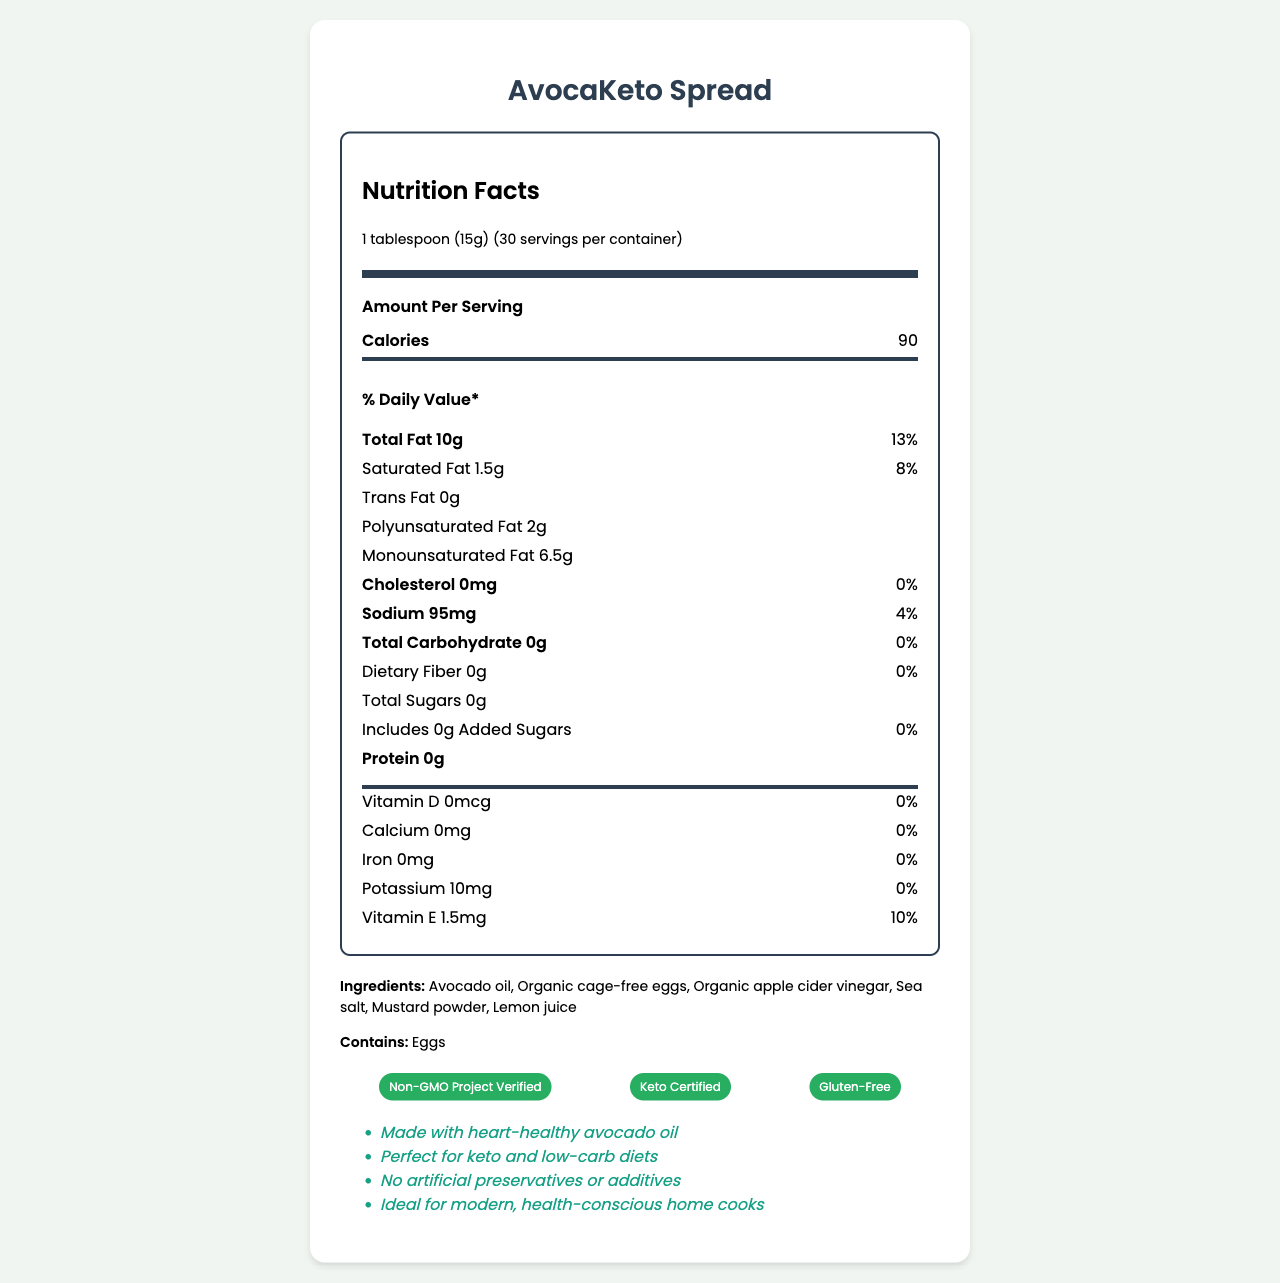what is the serving size? The serving size is explicitly stated as "1 tablespoon (15g)" in the document.
Answer: 1 tablespoon (15g) how many servings are in the container? The document states there are 30 servings per container.
Answer: 30 how many calories are in one serving? The document clearly shows that each serving contains 90 calories.
Answer: 90 calories what is the total fat content per serving? The document lists "Total Fat: 10g" under the nutrient section.
Answer: 10g what allergens are listed? The allergens section states "Contains: Eggs".
Answer: Eggs how much sodium does a serving contain? The document mentions that each serving contains "Sodium: 95mg".
Answer: 95mg how much protein is in a serving of AvocaKeto Spread? The protein content per serving is listed as 0g in the document.
Answer: 0g which certification(s) does AvocaKeto Spread have? A. Organic Certified B. Non-GMO Project Verified C. Vegan Certified The certifications section lists "Non-GMO Project Verified" among others.
Answer: B. Non-GMO Project Verified which ingredient is not present in AvocaKeto Spread? A. Lemon Juice B. Sugar C. Mustard Powder The ingredients section lists "Lemon juice" and "Mustard powder" but does not list "Sugar."
Answer: B. Sugar is there any cholesterol in AvocaKeto Spread? The cholesterol content is stated as "0mg" with a daily value percentage of "0%."
Answer: No does AvocaKeto Spread contain trans fats? The document indicates "Trans Fat: 0g."
Answer: No summarize the nutrition benefits of AvocaKeto Spread. The summary encapsulates the key nutritional aspects such as being keto-friendly, low in carbs, and healthy fats while also highlighting certifications and suitability for health-minded consumers.
Answer: AvocaKeto Spread is a keto-friendly, non-GMO alternative made primarily of avocado oil. It is low in carbohydrates, contains 10g of healthy fats per serving, including monounsaturated fats, and has no cholesterol, trans fats, or added sugars. It is additionally certified gluten-free and keto-friendly, making it suitable for health-conscious eaters. how long can AvocaKeto Spread be stored after opening? The storage instructions state to refrigerate after opening and use within 60 days.
Answer: 60 days what company produces AvocaKeto Spread? The manufacturer info lists "Green Kitchen Innovations" as the producer.
Answer: Green Kitchen Innovations what is the primary oil used in AvocaKeto Spread? The ingredients list starts with "Avocado oil," indicating it is the primary oil used.
Answer: Avocado oil does AvocaKeto Spread contain any artificial preservatives? The marketing claims section highlights "No artificial preservatives or additives."
Answer: No where is Green Kitchen Innovations located? The document does not provide the full address of Green Kitchen Innovations, only stating "San Francisco, CA."
Answer: Not enough information how much vitamin E is in one serving of AvocaKeto Spread? The document states the vitamin E content as "1.5mg" per serving.
Answer: 1.5mg 